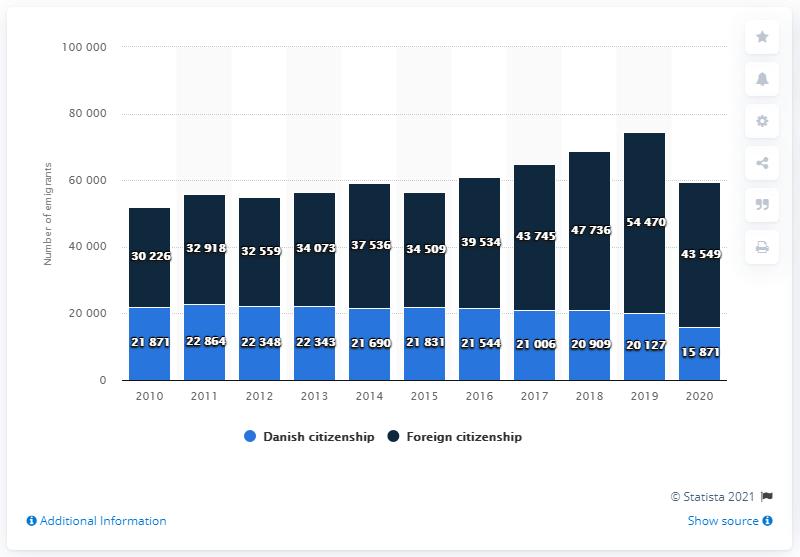Outline some significant characteristics in this image. In 2020, there were 15,871 Danish citizens who moved abroad. In 2020, approximately 43,549 people living in Denmark who held foreign citizenships emigrated from Denmark. 